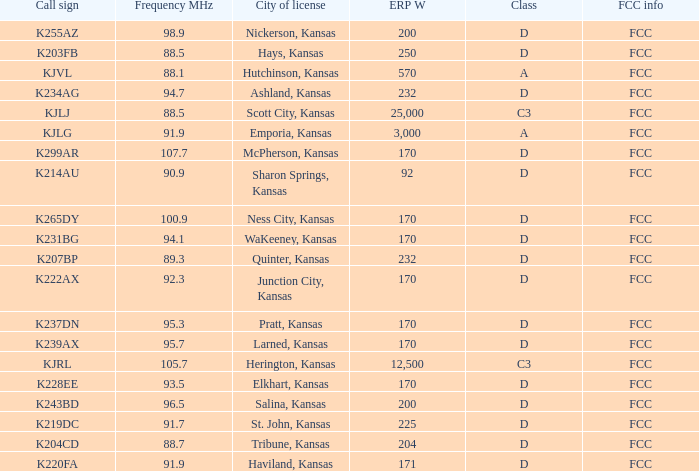Class of d, and a Frequency MHz smaller than 107.7, and a ERP W smaller than 232 has what call sign? K255AZ, K228EE, K220FA, K265DY, K237DN, K214AU, K222AX, K239AX, K243BD, K219DC, K204CD, K231BG. 